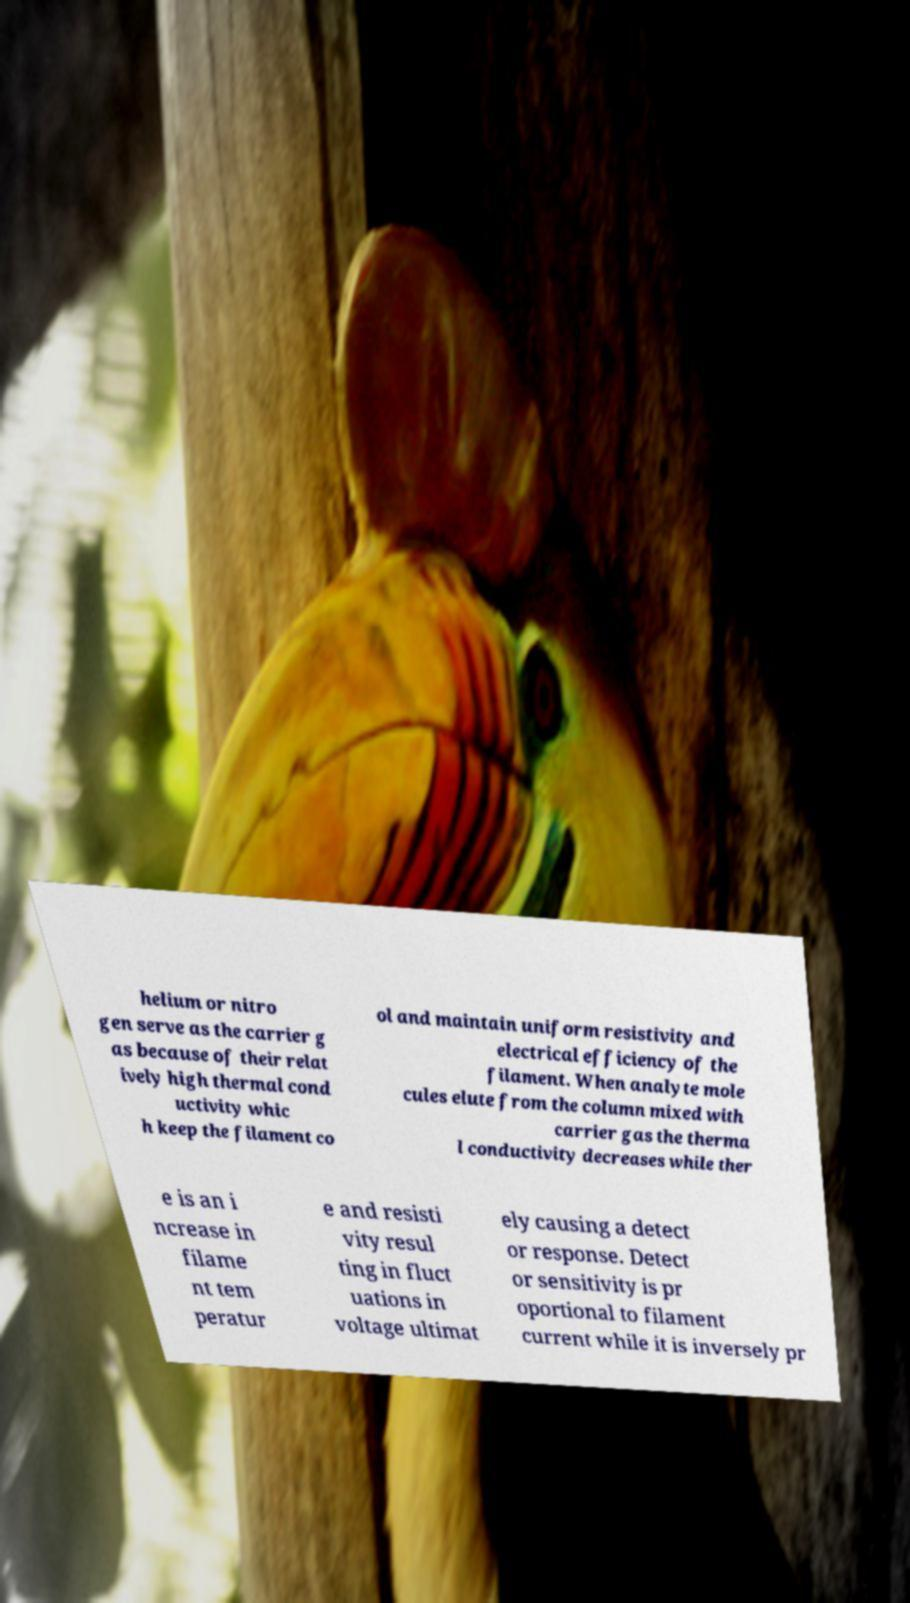I need the written content from this picture converted into text. Can you do that? helium or nitro gen serve as the carrier g as because of their relat ively high thermal cond uctivity whic h keep the filament co ol and maintain uniform resistivity and electrical efficiency of the filament. When analyte mole cules elute from the column mixed with carrier gas the therma l conductivity decreases while ther e is an i ncrease in filame nt tem peratur e and resisti vity resul ting in fluct uations in voltage ultimat ely causing a detect or response. Detect or sensitivity is pr oportional to filament current while it is inversely pr 